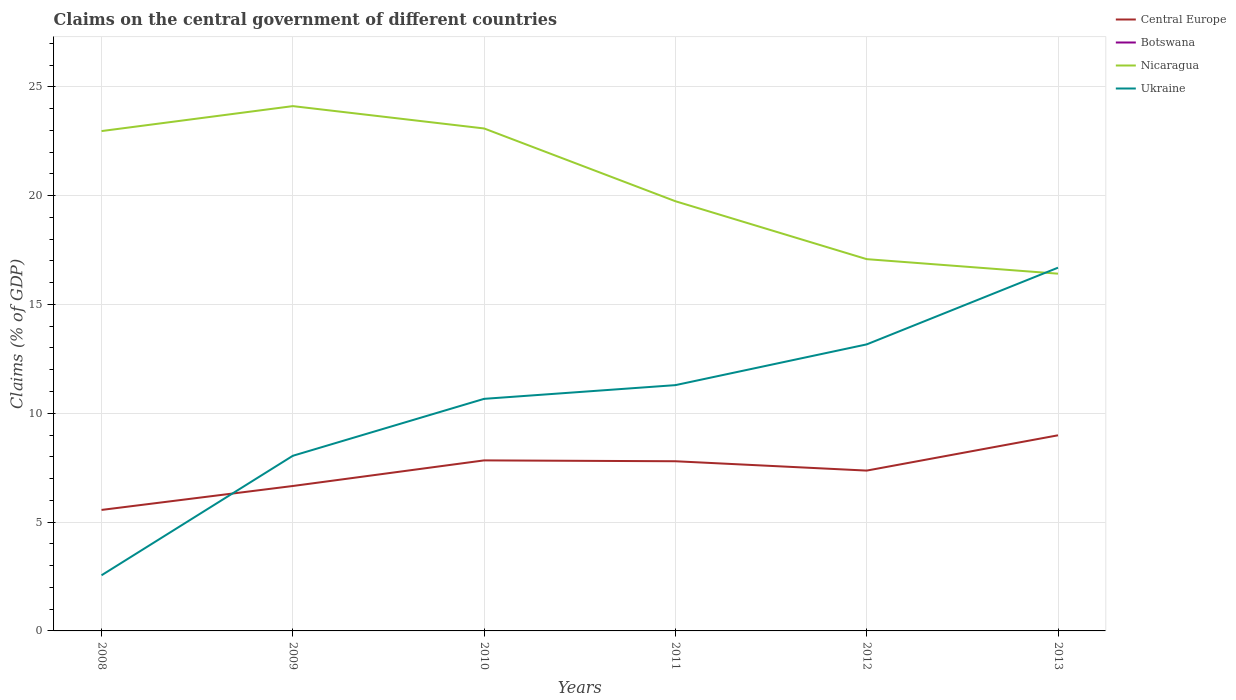Does the line corresponding to Central Europe intersect with the line corresponding to Botswana?
Your answer should be very brief. No. Is the number of lines equal to the number of legend labels?
Provide a short and direct response. No. What is the total percentage of GDP claimed on the central government in Central Europe in the graph?
Your answer should be very brief. -1.1. What is the difference between the highest and the second highest percentage of GDP claimed on the central government in Nicaragua?
Your response must be concise. 7.7. What is the difference between the highest and the lowest percentage of GDP claimed on the central government in Central Europe?
Provide a succinct answer. 3. Is the percentage of GDP claimed on the central government in Botswana strictly greater than the percentage of GDP claimed on the central government in Nicaragua over the years?
Provide a succinct answer. Yes. Where does the legend appear in the graph?
Provide a short and direct response. Top right. How are the legend labels stacked?
Provide a short and direct response. Vertical. What is the title of the graph?
Provide a short and direct response. Claims on the central government of different countries. Does "High income: OECD" appear as one of the legend labels in the graph?
Your answer should be compact. No. What is the label or title of the Y-axis?
Make the answer very short. Claims (% of GDP). What is the Claims (% of GDP) of Central Europe in 2008?
Make the answer very short. 5.56. What is the Claims (% of GDP) in Botswana in 2008?
Give a very brief answer. 0. What is the Claims (% of GDP) of Nicaragua in 2008?
Ensure brevity in your answer.  22.97. What is the Claims (% of GDP) of Ukraine in 2008?
Offer a terse response. 2.56. What is the Claims (% of GDP) of Central Europe in 2009?
Your answer should be compact. 6.66. What is the Claims (% of GDP) of Botswana in 2009?
Give a very brief answer. 0. What is the Claims (% of GDP) of Nicaragua in 2009?
Offer a very short reply. 24.11. What is the Claims (% of GDP) in Ukraine in 2009?
Your response must be concise. 8.05. What is the Claims (% of GDP) in Central Europe in 2010?
Provide a short and direct response. 7.84. What is the Claims (% of GDP) of Nicaragua in 2010?
Make the answer very short. 23.09. What is the Claims (% of GDP) of Ukraine in 2010?
Offer a terse response. 10.66. What is the Claims (% of GDP) in Central Europe in 2011?
Give a very brief answer. 7.8. What is the Claims (% of GDP) in Nicaragua in 2011?
Provide a short and direct response. 19.74. What is the Claims (% of GDP) of Ukraine in 2011?
Offer a terse response. 11.29. What is the Claims (% of GDP) of Central Europe in 2012?
Your answer should be very brief. 7.37. What is the Claims (% of GDP) in Botswana in 2012?
Ensure brevity in your answer.  0. What is the Claims (% of GDP) in Nicaragua in 2012?
Offer a terse response. 17.08. What is the Claims (% of GDP) in Ukraine in 2012?
Keep it short and to the point. 13.17. What is the Claims (% of GDP) in Central Europe in 2013?
Your answer should be compact. 8.99. What is the Claims (% of GDP) in Botswana in 2013?
Provide a succinct answer. 0. What is the Claims (% of GDP) in Nicaragua in 2013?
Offer a terse response. 16.41. What is the Claims (% of GDP) in Ukraine in 2013?
Your response must be concise. 16.69. Across all years, what is the maximum Claims (% of GDP) in Central Europe?
Your answer should be very brief. 8.99. Across all years, what is the maximum Claims (% of GDP) in Nicaragua?
Your answer should be very brief. 24.11. Across all years, what is the maximum Claims (% of GDP) in Ukraine?
Your answer should be compact. 16.69. Across all years, what is the minimum Claims (% of GDP) in Central Europe?
Offer a very short reply. 5.56. Across all years, what is the minimum Claims (% of GDP) in Nicaragua?
Keep it short and to the point. 16.41. Across all years, what is the minimum Claims (% of GDP) of Ukraine?
Ensure brevity in your answer.  2.56. What is the total Claims (% of GDP) in Central Europe in the graph?
Make the answer very short. 44.21. What is the total Claims (% of GDP) of Nicaragua in the graph?
Your answer should be very brief. 123.41. What is the total Claims (% of GDP) in Ukraine in the graph?
Your answer should be very brief. 62.42. What is the difference between the Claims (% of GDP) in Central Europe in 2008 and that in 2009?
Keep it short and to the point. -1.1. What is the difference between the Claims (% of GDP) in Nicaragua in 2008 and that in 2009?
Provide a succinct answer. -1.15. What is the difference between the Claims (% of GDP) in Ukraine in 2008 and that in 2009?
Your answer should be compact. -5.49. What is the difference between the Claims (% of GDP) of Central Europe in 2008 and that in 2010?
Your answer should be compact. -2.28. What is the difference between the Claims (% of GDP) in Nicaragua in 2008 and that in 2010?
Keep it short and to the point. -0.12. What is the difference between the Claims (% of GDP) of Ukraine in 2008 and that in 2010?
Your response must be concise. -8.11. What is the difference between the Claims (% of GDP) in Central Europe in 2008 and that in 2011?
Your response must be concise. -2.24. What is the difference between the Claims (% of GDP) in Nicaragua in 2008 and that in 2011?
Make the answer very short. 3.22. What is the difference between the Claims (% of GDP) of Ukraine in 2008 and that in 2011?
Keep it short and to the point. -8.74. What is the difference between the Claims (% of GDP) of Central Europe in 2008 and that in 2012?
Provide a short and direct response. -1.81. What is the difference between the Claims (% of GDP) in Nicaragua in 2008 and that in 2012?
Your response must be concise. 5.88. What is the difference between the Claims (% of GDP) in Ukraine in 2008 and that in 2012?
Your answer should be very brief. -10.61. What is the difference between the Claims (% of GDP) of Central Europe in 2008 and that in 2013?
Keep it short and to the point. -3.43. What is the difference between the Claims (% of GDP) of Nicaragua in 2008 and that in 2013?
Make the answer very short. 6.55. What is the difference between the Claims (% of GDP) of Ukraine in 2008 and that in 2013?
Provide a short and direct response. -14.13. What is the difference between the Claims (% of GDP) in Central Europe in 2009 and that in 2010?
Provide a short and direct response. -1.18. What is the difference between the Claims (% of GDP) in Nicaragua in 2009 and that in 2010?
Offer a terse response. 1.03. What is the difference between the Claims (% of GDP) in Ukraine in 2009 and that in 2010?
Your answer should be compact. -2.62. What is the difference between the Claims (% of GDP) in Central Europe in 2009 and that in 2011?
Make the answer very short. -1.14. What is the difference between the Claims (% of GDP) of Nicaragua in 2009 and that in 2011?
Offer a terse response. 4.37. What is the difference between the Claims (% of GDP) in Ukraine in 2009 and that in 2011?
Ensure brevity in your answer.  -3.25. What is the difference between the Claims (% of GDP) in Central Europe in 2009 and that in 2012?
Give a very brief answer. -0.71. What is the difference between the Claims (% of GDP) of Nicaragua in 2009 and that in 2012?
Offer a very short reply. 7.03. What is the difference between the Claims (% of GDP) in Ukraine in 2009 and that in 2012?
Provide a succinct answer. -5.12. What is the difference between the Claims (% of GDP) in Central Europe in 2009 and that in 2013?
Provide a short and direct response. -2.33. What is the difference between the Claims (% of GDP) in Nicaragua in 2009 and that in 2013?
Provide a short and direct response. 7.7. What is the difference between the Claims (% of GDP) in Ukraine in 2009 and that in 2013?
Your answer should be very brief. -8.64. What is the difference between the Claims (% of GDP) of Central Europe in 2010 and that in 2011?
Give a very brief answer. 0.04. What is the difference between the Claims (% of GDP) of Nicaragua in 2010 and that in 2011?
Offer a terse response. 3.34. What is the difference between the Claims (% of GDP) of Ukraine in 2010 and that in 2011?
Give a very brief answer. -0.63. What is the difference between the Claims (% of GDP) of Central Europe in 2010 and that in 2012?
Provide a succinct answer. 0.47. What is the difference between the Claims (% of GDP) of Nicaragua in 2010 and that in 2012?
Your response must be concise. 6. What is the difference between the Claims (% of GDP) in Ukraine in 2010 and that in 2012?
Offer a very short reply. -2.5. What is the difference between the Claims (% of GDP) in Central Europe in 2010 and that in 2013?
Offer a terse response. -1.15. What is the difference between the Claims (% of GDP) in Nicaragua in 2010 and that in 2013?
Keep it short and to the point. 6.67. What is the difference between the Claims (% of GDP) of Ukraine in 2010 and that in 2013?
Offer a very short reply. -6.03. What is the difference between the Claims (% of GDP) in Central Europe in 2011 and that in 2012?
Offer a terse response. 0.43. What is the difference between the Claims (% of GDP) of Nicaragua in 2011 and that in 2012?
Offer a terse response. 2.66. What is the difference between the Claims (% of GDP) of Ukraine in 2011 and that in 2012?
Make the answer very short. -1.87. What is the difference between the Claims (% of GDP) of Central Europe in 2011 and that in 2013?
Ensure brevity in your answer.  -1.19. What is the difference between the Claims (% of GDP) in Nicaragua in 2011 and that in 2013?
Provide a short and direct response. 3.33. What is the difference between the Claims (% of GDP) in Ukraine in 2011 and that in 2013?
Your answer should be compact. -5.4. What is the difference between the Claims (% of GDP) in Central Europe in 2012 and that in 2013?
Offer a terse response. -1.62. What is the difference between the Claims (% of GDP) of Nicaragua in 2012 and that in 2013?
Give a very brief answer. 0.67. What is the difference between the Claims (% of GDP) of Ukraine in 2012 and that in 2013?
Your answer should be compact. -3.52. What is the difference between the Claims (% of GDP) of Central Europe in 2008 and the Claims (% of GDP) of Nicaragua in 2009?
Your response must be concise. -18.55. What is the difference between the Claims (% of GDP) in Central Europe in 2008 and the Claims (% of GDP) in Ukraine in 2009?
Your response must be concise. -2.49. What is the difference between the Claims (% of GDP) in Nicaragua in 2008 and the Claims (% of GDP) in Ukraine in 2009?
Provide a short and direct response. 14.92. What is the difference between the Claims (% of GDP) of Central Europe in 2008 and the Claims (% of GDP) of Nicaragua in 2010?
Provide a short and direct response. -17.53. What is the difference between the Claims (% of GDP) in Central Europe in 2008 and the Claims (% of GDP) in Ukraine in 2010?
Offer a terse response. -5.1. What is the difference between the Claims (% of GDP) in Nicaragua in 2008 and the Claims (% of GDP) in Ukraine in 2010?
Provide a short and direct response. 12.3. What is the difference between the Claims (% of GDP) of Central Europe in 2008 and the Claims (% of GDP) of Nicaragua in 2011?
Ensure brevity in your answer.  -14.18. What is the difference between the Claims (% of GDP) in Central Europe in 2008 and the Claims (% of GDP) in Ukraine in 2011?
Provide a succinct answer. -5.73. What is the difference between the Claims (% of GDP) in Nicaragua in 2008 and the Claims (% of GDP) in Ukraine in 2011?
Provide a short and direct response. 11.67. What is the difference between the Claims (% of GDP) in Central Europe in 2008 and the Claims (% of GDP) in Nicaragua in 2012?
Make the answer very short. -11.52. What is the difference between the Claims (% of GDP) of Central Europe in 2008 and the Claims (% of GDP) of Ukraine in 2012?
Your answer should be compact. -7.61. What is the difference between the Claims (% of GDP) of Nicaragua in 2008 and the Claims (% of GDP) of Ukraine in 2012?
Provide a succinct answer. 9.8. What is the difference between the Claims (% of GDP) of Central Europe in 2008 and the Claims (% of GDP) of Nicaragua in 2013?
Make the answer very short. -10.86. What is the difference between the Claims (% of GDP) of Central Europe in 2008 and the Claims (% of GDP) of Ukraine in 2013?
Offer a very short reply. -11.13. What is the difference between the Claims (% of GDP) of Nicaragua in 2008 and the Claims (% of GDP) of Ukraine in 2013?
Make the answer very short. 6.28. What is the difference between the Claims (% of GDP) of Central Europe in 2009 and the Claims (% of GDP) of Nicaragua in 2010?
Give a very brief answer. -16.43. What is the difference between the Claims (% of GDP) in Central Europe in 2009 and the Claims (% of GDP) in Ukraine in 2010?
Provide a short and direct response. -4. What is the difference between the Claims (% of GDP) in Nicaragua in 2009 and the Claims (% of GDP) in Ukraine in 2010?
Keep it short and to the point. 13.45. What is the difference between the Claims (% of GDP) of Central Europe in 2009 and the Claims (% of GDP) of Nicaragua in 2011?
Your answer should be very brief. -13.08. What is the difference between the Claims (% of GDP) of Central Europe in 2009 and the Claims (% of GDP) of Ukraine in 2011?
Your response must be concise. -4.63. What is the difference between the Claims (% of GDP) in Nicaragua in 2009 and the Claims (% of GDP) in Ukraine in 2011?
Ensure brevity in your answer.  12.82. What is the difference between the Claims (% of GDP) in Central Europe in 2009 and the Claims (% of GDP) in Nicaragua in 2012?
Offer a very short reply. -10.42. What is the difference between the Claims (% of GDP) of Central Europe in 2009 and the Claims (% of GDP) of Ukraine in 2012?
Provide a short and direct response. -6.51. What is the difference between the Claims (% of GDP) in Nicaragua in 2009 and the Claims (% of GDP) in Ukraine in 2012?
Offer a terse response. 10.95. What is the difference between the Claims (% of GDP) of Central Europe in 2009 and the Claims (% of GDP) of Nicaragua in 2013?
Your response must be concise. -9.76. What is the difference between the Claims (% of GDP) in Central Europe in 2009 and the Claims (% of GDP) in Ukraine in 2013?
Your response must be concise. -10.03. What is the difference between the Claims (% of GDP) of Nicaragua in 2009 and the Claims (% of GDP) of Ukraine in 2013?
Your answer should be compact. 7.42. What is the difference between the Claims (% of GDP) of Central Europe in 2010 and the Claims (% of GDP) of Nicaragua in 2011?
Ensure brevity in your answer.  -11.91. What is the difference between the Claims (% of GDP) of Central Europe in 2010 and the Claims (% of GDP) of Ukraine in 2011?
Your response must be concise. -3.46. What is the difference between the Claims (% of GDP) in Nicaragua in 2010 and the Claims (% of GDP) in Ukraine in 2011?
Offer a very short reply. 11.79. What is the difference between the Claims (% of GDP) in Central Europe in 2010 and the Claims (% of GDP) in Nicaragua in 2012?
Keep it short and to the point. -9.25. What is the difference between the Claims (% of GDP) of Central Europe in 2010 and the Claims (% of GDP) of Ukraine in 2012?
Make the answer very short. -5.33. What is the difference between the Claims (% of GDP) in Nicaragua in 2010 and the Claims (% of GDP) in Ukraine in 2012?
Provide a succinct answer. 9.92. What is the difference between the Claims (% of GDP) in Central Europe in 2010 and the Claims (% of GDP) in Nicaragua in 2013?
Your response must be concise. -8.58. What is the difference between the Claims (% of GDP) in Central Europe in 2010 and the Claims (% of GDP) in Ukraine in 2013?
Offer a very short reply. -8.85. What is the difference between the Claims (% of GDP) in Nicaragua in 2010 and the Claims (% of GDP) in Ukraine in 2013?
Provide a short and direct response. 6.4. What is the difference between the Claims (% of GDP) of Central Europe in 2011 and the Claims (% of GDP) of Nicaragua in 2012?
Offer a terse response. -9.29. What is the difference between the Claims (% of GDP) of Central Europe in 2011 and the Claims (% of GDP) of Ukraine in 2012?
Your answer should be compact. -5.37. What is the difference between the Claims (% of GDP) of Nicaragua in 2011 and the Claims (% of GDP) of Ukraine in 2012?
Make the answer very short. 6.58. What is the difference between the Claims (% of GDP) of Central Europe in 2011 and the Claims (% of GDP) of Nicaragua in 2013?
Provide a short and direct response. -8.62. What is the difference between the Claims (% of GDP) of Central Europe in 2011 and the Claims (% of GDP) of Ukraine in 2013?
Provide a short and direct response. -8.89. What is the difference between the Claims (% of GDP) of Nicaragua in 2011 and the Claims (% of GDP) of Ukraine in 2013?
Make the answer very short. 3.05. What is the difference between the Claims (% of GDP) in Central Europe in 2012 and the Claims (% of GDP) in Nicaragua in 2013?
Your answer should be compact. -9.05. What is the difference between the Claims (% of GDP) in Central Europe in 2012 and the Claims (% of GDP) in Ukraine in 2013?
Offer a very short reply. -9.32. What is the difference between the Claims (% of GDP) of Nicaragua in 2012 and the Claims (% of GDP) of Ukraine in 2013?
Provide a succinct answer. 0.39. What is the average Claims (% of GDP) of Central Europe per year?
Your response must be concise. 7.37. What is the average Claims (% of GDP) in Nicaragua per year?
Your answer should be very brief. 20.57. What is the average Claims (% of GDP) in Ukraine per year?
Give a very brief answer. 10.4. In the year 2008, what is the difference between the Claims (% of GDP) in Central Europe and Claims (% of GDP) in Nicaragua?
Give a very brief answer. -17.41. In the year 2008, what is the difference between the Claims (% of GDP) of Central Europe and Claims (% of GDP) of Ukraine?
Offer a very short reply. 3. In the year 2008, what is the difference between the Claims (% of GDP) in Nicaragua and Claims (% of GDP) in Ukraine?
Your answer should be very brief. 20.41. In the year 2009, what is the difference between the Claims (% of GDP) of Central Europe and Claims (% of GDP) of Nicaragua?
Provide a succinct answer. -17.45. In the year 2009, what is the difference between the Claims (% of GDP) in Central Europe and Claims (% of GDP) in Ukraine?
Make the answer very short. -1.39. In the year 2009, what is the difference between the Claims (% of GDP) in Nicaragua and Claims (% of GDP) in Ukraine?
Make the answer very short. 16.07. In the year 2010, what is the difference between the Claims (% of GDP) of Central Europe and Claims (% of GDP) of Nicaragua?
Keep it short and to the point. -15.25. In the year 2010, what is the difference between the Claims (% of GDP) in Central Europe and Claims (% of GDP) in Ukraine?
Your answer should be very brief. -2.83. In the year 2010, what is the difference between the Claims (% of GDP) in Nicaragua and Claims (% of GDP) in Ukraine?
Offer a terse response. 12.42. In the year 2011, what is the difference between the Claims (% of GDP) of Central Europe and Claims (% of GDP) of Nicaragua?
Your response must be concise. -11.95. In the year 2011, what is the difference between the Claims (% of GDP) of Central Europe and Claims (% of GDP) of Ukraine?
Give a very brief answer. -3.5. In the year 2011, what is the difference between the Claims (% of GDP) in Nicaragua and Claims (% of GDP) in Ukraine?
Your answer should be very brief. 8.45. In the year 2012, what is the difference between the Claims (% of GDP) of Central Europe and Claims (% of GDP) of Nicaragua?
Your answer should be compact. -9.72. In the year 2012, what is the difference between the Claims (% of GDP) in Central Europe and Claims (% of GDP) in Ukraine?
Make the answer very short. -5.8. In the year 2012, what is the difference between the Claims (% of GDP) in Nicaragua and Claims (% of GDP) in Ukraine?
Offer a very short reply. 3.92. In the year 2013, what is the difference between the Claims (% of GDP) of Central Europe and Claims (% of GDP) of Nicaragua?
Offer a very short reply. -7.43. In the year 2013, what is the difference between the Claims (% of GDP) in Central Europe and Claims (% of GDP) in Ukraine?
Your answer should be very brief. -7.7. In the year 2013, what is the difference between the Claims (% of GDP) in Nicaragua and Claims (% of GDP) in Ukraine?
Ensure brevity in your answer.  -0.28. What is the ratio of the Claims (% of GDP) in Central Europe in 2008 to that in 2009?
Offer a terse response. 0.83. What is the ratio of the Claims (% of GDP) of Nicaragua in 2008 to that in 2009?
Make the answer very short. 0.95. What is the ratio of the Claims (% of GDP) of Ukraine in 2008 to that in 2009?
Offer a terse response. 0.32. What is the ratio of the Claims (% of GDP) of Central Europe in 2008 to that in 2010?
Ensure brevity in your answer.  0.71. What is the ratio of the Claims (% of GDP) in Ukraine in 2008 to that in 2010?
Your response must be concise. 0.24. What is the ratio of the Claims (% of GDP) in Central Europe in 2008 to that in 2011?
Provide a succinct answer. 0.71. What is the ratio of the Claims (% of GDP) of Nicaragua in 2008 to that in 2011?
Provide a short and direct response. 1.16. What is the ratio of the Claims (% of GDP) in Ukraine in 2008 to that in 2011?
Provide a succinct answer. 0.23. What is the ratio of the Claims (% of GDP) in Central Europe in 2008 to that in 2012?
Give a very brief answer. 0.75. What is the ratio of the Claims (% of GDP) in Nicaragua in 2008 to that in 2012?
Make the answer very short. 1.34. What is the ratio of the Claims (% of GDP) of Ukraine in 2008 to that in 2012?
Your answer should be compact. 0.19. What is the ratio of the Claims (% of GDP) in Central Europe in 2008 to that in 2013?
Keep it short and to the point. 0.62. What is the ratio of the Claims (% of GDP) in Nicaragua in 2008 to that in 2013?
Give a very brief answer. 1.4. What is the ratio of the Claims (% of GDP) of Ukraine in 2008 to that in 2013?
Provide a short and direct response. 0.15. What is the ratio of the Claims (% of GDP) of Central Europe in 2009 to that in 2010?
Provide a succinct answer. 0.85. What is the ratio of the Claims (% of GDP) of Nicaragua in 2009 to that in 2010?
Give a very brief answer. 1.04. What is the ratio of the Claims (% of GDP) in Ukraine in 2009 to that in 2010?
Your answer should be compact. 0.75. What is the ratio of the Claims (% of GDP) in Central Europe in 2009 to that in 2011?
Ensure brevity in your answer.  0.85. What is the ratio of the Claims (% of GDP) in Nicaragua in 2009 to that in 2011?
Keep it short and to the point. 1.22. What is the ratio of the Claims (% of GDP) in Ukraine in 2009 to that in 2011?
Give a very brief answer. 0.71. What is the ratio of the Claims (% of GDP) of Central Europe in 2009 to that in 2012?
Provide a short and direct response. 0.9. What is the ratio of the Claims (% of GDP) in Nicaragua in 2009 to that in 2012?
Ensure brevity in your answer.  1.41. What is the ratio of the Claims (% of GDP) in Ukraine in 2009 to that in 2012?
Give a very brief answer. 0.61. What is the ratio of the Claims (% of GDP) in Central Europe in 2009 to that in 2013?
Your answer should be very brief. 0.74. What is the ratio of the Claims (% of GDP) in Nicaragua in 2009 to that in 2013?
Make the answer very short. 1.47. What is the ratio of the Claims (% of GDP) of Ukraine in 2009 to that in 2013?
Your answer should be compact. 0.48. What is the ratio of the Claims (% of GDP) of Nicaragua in 2010 to that in 2011?
Your response must be concise. 1.17. What is the ratio of the Claims (% of GDP) of Ukraine in 2010 to that in 2011?
Your response must be concise. 0.94. What is the ratio of the Claims (% of GDP) in Central Europe in 2010 to that in 2012?
Keep it short and to the point. 1.06. What is the ratio of the Claims (% of GDP) in Nicaragua in 2010 to that in 2012?
Your answer should be very brief. 1.35. What is the ratio of the Claims (% of GDP) in Ukraine in 2010 to that in 2012?
Provide a succinct answer. 0.81. What is the ratio of the Claims (% of GDP) in Central Europe in 2010 to that in 2013?
Provide a succinct answer. 0.87. What is the ratio of the Claims (% of GDP) of Nicaragua in 2010 to that in 2013?
Offer a terse response. 1.41. What is the ratio of the Claims (% of GDP) of Ukraine in 2010 to that in 2013?
Your answer should be very brief. 0.64. What is the ratio of the Claims (% of GDP) in Central Europe in 2011 to that in 2012?
Ensure brevity in your answer.  1.06. What is the ratio of the Claims (% of GDP) of Nicaragua in 2011 to that in 2012?
Offer a very short reply. 1.16. What is the ratio of the Claims (% of GDP) of Ukraine in 2011 to that in 2012?
Your answer should be very brief. 0.86. What is the ratio of the Claims (% of GDP) in Central Europe in 2011 to that in 2013?
Give a very brief answer. 0.87. What is the ratio of the Claims (% of GDP) of Nicaragua in 2011 to that in 2013?
Ensure brevity in your answer.  1.2. What is the ratio of the Claims (% of GDP) of Ukraine in 2011 to that in 2013?
Keep it short and to the point. 0.68. What is the ratio of the Claims (% of GDP) in Central Europe in 2012 to that in 2013?
Keep it short and to the point. 0.82. What is the ratio of the Claims (% of GDP) in Nicaragua in 2012 to that in 2013?
Keep it short and to the point. 1.04. What is the ratio of the Claims (% of GDP) in Ukraine in 2012 to that in 2013?
Keep it short and to the point. 0.79. What is the difference between the highest and the second highest Claims (% of GDP) in Central Europe?
Provide a succinct answer. 1.15. What is the difference between the highest and the second highest Claims (% of GDP) of Nicaragua?
Give a very brief answer. 1.03. What is the difference between the highest and the second highest Claims (% of GDP) of Ukraine?
Offer a terse response. 3.52. What is the difference between the highest and the lowest Claims (% of GDP) in Central Europe?
Offer a very short reply. 3.43. What is the difference between the highest and the lowest Claims (% of GDP) of Nicaragua?
Make the answer very short. 7.7. What is the difference between the highest and the lowest Claims (% of GDP) of Ukraine?
Provide a short and direct response. 14.13. 